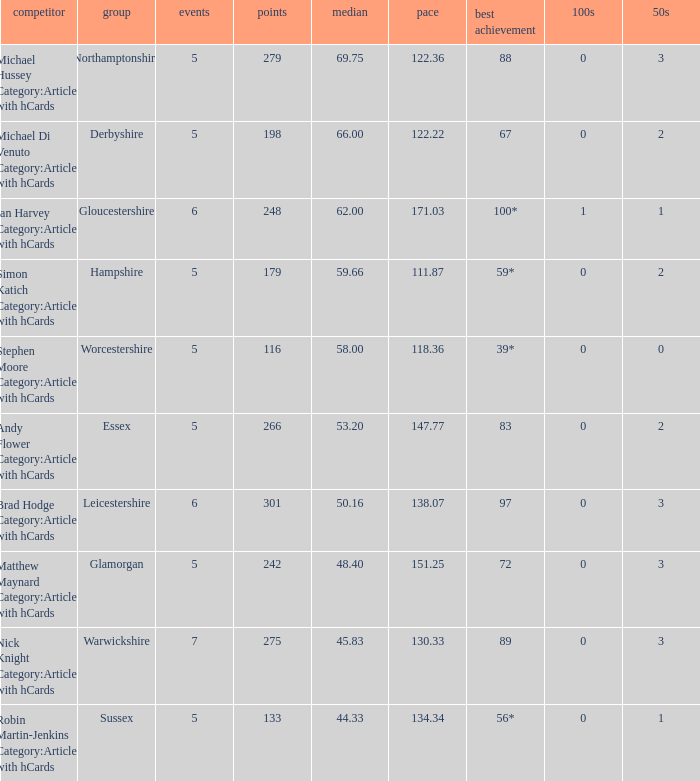What is the smallest amount of matches? 5.0. Parse the table in full. {'header': ['competitor', 'group', 'events', 'points', 'median', 'pace', 'best achievement', '100s', '50s'], 'rows': [['Michael Hussey Category:Articles with hCards', 'Northamptonshire', '5', '279', '69.75', '122.36', '88', '0', '3'], ['Michael Di Venuto Category:Articles with hCards', 'Derbyshire', '5', '198', '66.00', '122.22', '67', '0', '2'], ['Ian Harvey Category:Articles with hCards', 'Gloucestershire', '6', '248', '62.00', '171.03', '100*', '1', '1'], ['Simon Katich Category:Articles with hCards', 'Hampshire', '5', '179', '59.66', '111.87', '59*', '0', '2'], ['Stephen Moore Category:Articles with hCards', 'Worcestershire', '5', '116', '58.00', '118.36', '39*', '0', '0'], ['Andy Flower Category:Articles with hCards', 'Essex', '5', '266', '53.20', '147.77', '83', '0', '2'], ['Brad Hodge Category:Articles with hCards', 'Leicestershire', '6', '301', '50.16', '138.07', '97', '0', '3'], ['Matthew Maynard Category:Articles with hCards', 'Glamorgan', '5', '242', '48.40', '151.25', '72', '0', '3'], ['Nick Knight Category:Articles with hCards', 'Warwickshire', '7', '275', '45.83', '130.33', '89', '0', '3'], ['Robin Martin-Jenkins Category:Articles with hCards', 'Sussex', '5', '133', '44.33', '134.34', '56*', '0', '1']]} 